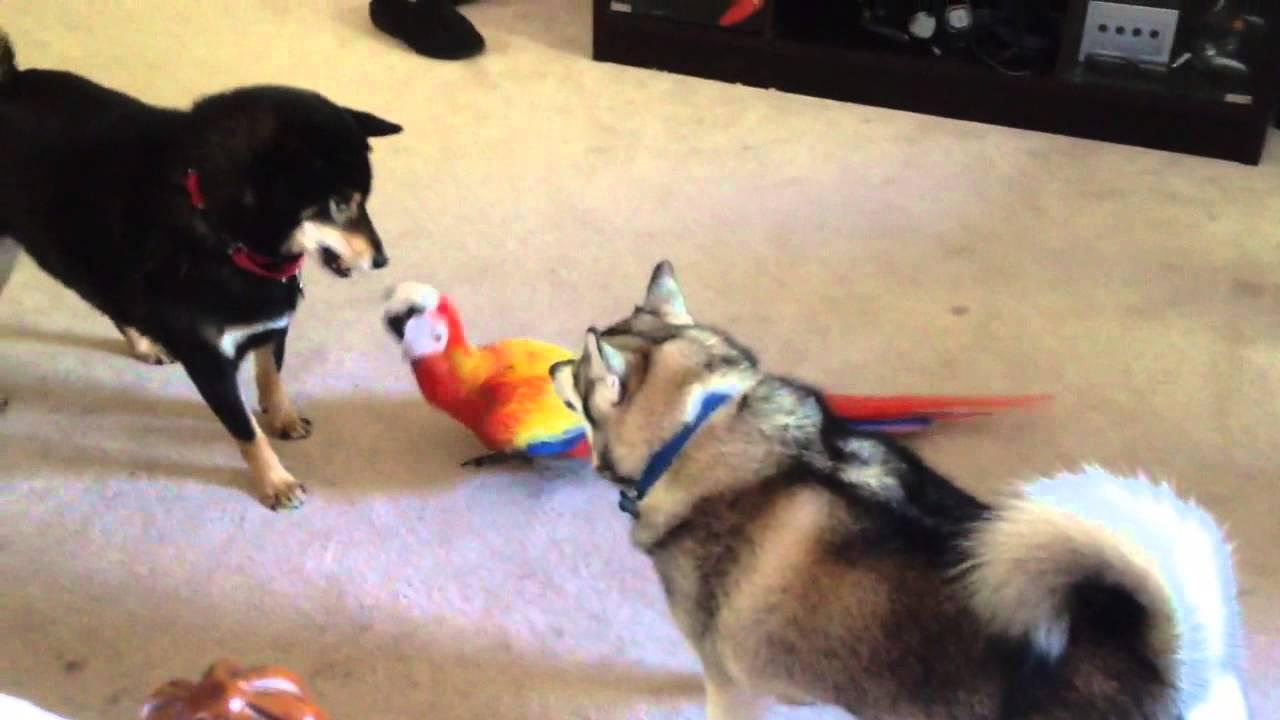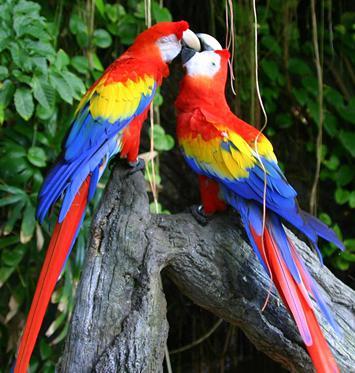The first image is the image on the left, the second image is the image on the right. Analyze the images presented: Is the assertion "Two parrots nuzzle, in the image on the right." valid? Answer yes or no. Yes. The first image is the image on the left, the second image is the image on the right. Considering the images on both sides, is "All birds shown have blue and yellow coloring, and at least one bird has its yellow belly facing the camera." valid? Answer yes or no. No. 